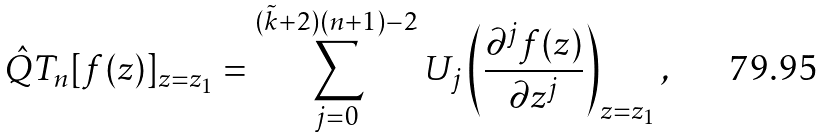Convert formula to latex. <formula><loc_0><loc_0><loc_500><loc_500>\hat { Q } T _ { n } [ f ( z ) ] _ { z = z _ { 1 } } = \sum _ { j = 0 } ^ { ( { \tilde { k } } + 2 ) ( n + 1 ) - 2 } U _ { j } \left ( \frac { \partial ^ { j } f ( z ) } { \partial z ^ { j } } \right ) _ { z = z _ { 1 } } ,</formula> 